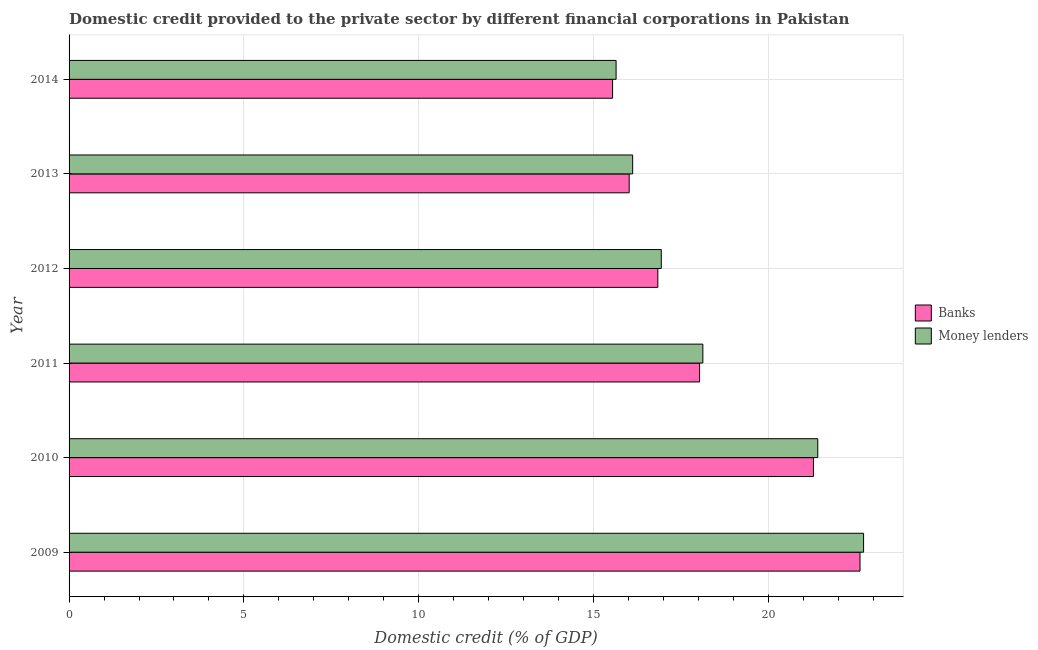How many different coloured bars are there?
Make the answer very short. 2. How many groups of bars are there?
Make the answer very short. 6. How many bars are there on the 1st tick from the top?
Keep it short and to the point. 2. How many bars are there on the 1st tick from the bottom?
Offer a very short reply. 2. What is the domestic credit provided by money lenders in 2011?
Offer a terse response. 18.13. Across all years, what is the maximum domestic credit provided by money lenders?
Make the answer very short. 22.72. Across all years, what is the minimum domestic credit provided by banks?
Offer a terse response. 15.54. What is the total domestic credit provided by money lenders in the graph?
Offer a terse response. 110.96. What is the difference between the domestic credit provided by money lenders in 2010 and that in 2012?
Provide a succinct answer. 4.48. What is the difference between the domestic credit provided by banks in 2009 and the domestic credit provided by money lenders in 2014?
Provide a succinct answer. 6.98. What is the average domestic credit provided by banks per year?
Your answer should be compact. 18.39. In the year 2012, what is the difference between the domestic credit provided by money lenders and domestic credit provided by banks?
Your answer should be compact. 0.1. What is the ratio of the domestic credit provided by banks in 2009 to that in 2014?
Offer a terse response. 1.46. Is the difference between the domestic credit provided by money lenders in 2009 and 2013 greater than the difference between the domestic credit provided by banks in 2009 and 2013?
Offer a very short reply. Yes. What is the difference between the highest and the second highest domestic credit provided by banks?
Keep it short and to the point. 1.33. What is the difference between the highest and the lowest domestic credit provided by money lenders?
Offer a terse response. 7.08. In how many years, is the domestic credit provided by banks greater than the average domestic credit provided by banks taken over all years?
Provide a succinct answer. 2. What does the 2nd bar from the top in 2009 represents?
Your answer should be very brief. Banks. What does the 1st bar from the bottom in 2009 represents?
Give a very brief answer. Banks. What is the difference between two consecutive major ticks on the X-axis?
Your answer should be compact. 5. Are the values on the major ticks of X-axis written in scientific E-notation?
Give a very brief answer. No. Where does the legend appear in the graph?
Make the answer very short. Center right. How are the legend labels stacked?
Your answer should be compact. Vertical. What is the title of the graph?
Ensure brevity in your answer.  Domestic credit provided to the private sector by different financial corporations in Pakistan. What is the label or title of the X-axis?
Keep it short and to the point. Domestic credit (% of GDP). What is the label or title of the Y-axis?
Your response must be concise. Year. What is the Domestic credit (% of GDP) of Banks in 2009?
Your answer should be very brief. 22.62. What is the Domestic credit (% of GDP) in Money lenders in 2009?
Give a very brief answer. 22.72. What is the Domestic credit (% of GDP) of Banks in 2010?
Keep it short and to the point. 21.29. What is the Domestic credit (% of GDP) of Money lenders in 2010?
Provide a short and direct response. 21.41. What is the Domestic credit (% of GDP) in Banks in 2011?
Offer a very short reply. 18.03. What is the Domestic credit (% of GDP) of Money lenders in 2011?
Your response must be concise. 18.13. What is the Domestic credit (% of GDP) of Banks in 2012?
Make the answer very short. 16.84. What is the Domestic credit (% of GDP) of Money lenders in 2012?
Provide a succinct answer. 16.94. What is the Domestic credit (% of GDP) in Banks in 2013?
Your answer should be compact. 16.02. What is the Domestic credit (% of GDP) in Money lenders in 2013?
Provide a succinct answer. 16.12. What is the Domestic credit (% of GDP) of Banks in 2014?
Give a very brief answer. 15.54. What is the Domestic credit (% of GDP) of Money lenders in 2014?
Your answer should be compact. 15.64. Across all years, what is the maximum Domestic credit (% of GDP) in Banks?
Give a very brief answer. 22.62. Across all years, what is the maximum Domestic credit (% of GDP) of Money lenders?
Make the answer very short. 22.72. Across all years, what is the minimum Domestic credit (% of GDP) of Banks?
Offer a terse response. 15.54. Across all years, what is the minimum Domestic credit (% of GDP) of Money lenders?
Give a very brief answer. 15.64. What is the total Domestic credit (% of GDP) in Banks in the graph?
Offer a terse response. 110.34. What is the total Domestic credit (% of GDP) in Money lenders in the graph?
Your answer should be very brief. 110.96. What is the difference between the Domestic credit (% of GDP) of Banks in 2009 and that in 2010?
Give a very brief answer. 1.33. What is the difference between the Domestic credit (% of GDP) in Money lenders in 2009 and that in 2010?
Provide a succinct answer. 1.31. What is the difference between the Domestic credit (% of GDP) of Banks in 2009 and that in 2011?
Keep it short and to the point. 4.59. What is the difference between the Domestic credit (% of GDP) of Money lenders in 2009 and that in 2011?
Offer a very short reply. 4.6. What is the difference between the Domestic credit (% of GDP) in Banks in 2009 and that in 2012?
Give a very brief answer. 5.78. What is the difference between the Domestic credit (% of GDP) of Money lenders in 2009 and that in 2012?
Your answer should be very brief. 5.79. What is the difference between the Domestic credit (% of GDP) in Banks in 2009 and that in 2013?
Provide a short and direct response. 6.6. What is the difference between the Domestic credit (% of GDP) of Money lenders in 2009 and that in 2013?
Make the answer very short. 6.6. What is the difference between the Domestic credit (% of GDP) in Banks in 2009 and that in 2014?
Provide a short and direct response. 7.08. What is the difference between the Domestic credit (% of GDP) of Money lenders in 2009 and that in 2014?
Ensure brevity in your answer.  7.08. What is the difference between the Domestic credit (% of GDP) in Banks in 2010 and that in 2011?
Make the answer very short. 3.26. What is the difference between the Domestic credit (% of GDP) of Money lenders in 2010 and that in 2011?
Your response must be concise. 3.29. What is the difference between the Domestic credit (% of GDP) of Banks in 2010 and that in 2012?
Offer a terse response. 4.45. What is the difference between the Domestic credit (% of GDP) of Money lenders in 2010 and that in 2012?
Ensure brevity in your answer.  4.48. What is the difference between the Domestic credit (% of GDP) of Banks in 2010 and that in 2013?
Provide a succinct answer. 5.27. What is the difference between the Domestic credit (% of GDP) in Money lenders in 2010 and that in 2013?
Provide a short and direct response. 5.29. What is the difference between the Domestic credit (% of GDP) of Banks in 2010 and that in 2014?
Your response must be concise. 5.74. What is the difference between the Domestic credit (% of GDP) of Money lenders in 2010 and that in 2014?
Your answer should be very brief. 5.77. What is the difference between the Domestic credit (% of GDP) of Banks in 2011 and that in 2012?
Provide a short and direct response. 1.19. What is the difference between the Domestic credit (% of GDP) of Money lenders in 2011 and that in 2012?
Provide a succinct answer. 1.19. What is the difference between the Domestic credit (% of GDP) of Banks in 2011 and that in 2013?
Provide a short and direct response. 2.01. What is the difference between the Domestic credit (% of GDP) of Money lenders in 2011 and that in 2013?
Your response must be concise. 2.01. What is the difference between the Domestic credit (% of GDP) of Banks in 2011 and that in 2014?
Offer a very short reply. 2.49. What is the difference between the Domestic credit (% of GDP) of Money lenders in 2011 and that in 2014?
Offer a terse response. 2.48. What is the difference between the Domestic credit (% of GDP) in Banks in 2012 and that in 2013?
Make the answer very short. 0.82. What is the difference between the Domestic credit (% of GDP) of Money lenders in 2012 and that in 2013?
Make the answer very short. 0.82. What is the difference between the Domestic credit (% of GDP) in Banks in 2012 and that in 2014?
Give a very brief answer. 1.29. What is the difference between the Domestic credit (% of GDP) of Money lenders in 2012 and that in 2014?
Provide a succinct answer. 1.29. What is the difference between the Domestic credit (% of GDP) in Banks in 2013 and that in 2014?
Offer a very short reply. 0.47. What is the difference between the Domestic credit (% of GDP) of Money lenders in 2013 and that in 2014?
Your response must be concise. 0.47. What is the difference between the Domestic credit (% of GDP) of Banks in 2009 and the Domestic credit (% of GDP) of Money lenders in 2010?
Your answer should be very brief. 1.21. What is the difference between the Domestic credit (% of GDP) of Banks in 2009 and the Domestic credit (% of GDP) of Money lenders in 2011?
Ensure brevity in your answer.  4.49. What is the difference between the Domestic credit (% of GDP) in Banks in 2009 and the Domestic credit (% of GDP) in Money lenders in 2012?
Give a very brief answer. 5.68. What is the difference between the Domestic credit (% of GDP) of Banks in 2009 and the Domestic credit (% of GDP) of Money lenders in 2013?
Your response must be concise. 6.5. What is the difference between the Domestic credit (% of GDP) of Banks in 2009 and the Domestic credit (% of GDP) of Money lenders in 2014?
Provide a short and direct response. 6.98. What is the difference between the Domestic credit (% of GDP) of Banks in 2010 and the Domestic credit (% of GDP) of Money lenders in 2011?
Make the answer very short. 3.16. What is the difference between the Domestic credit (% of GDP) of Banks in 2010 and the Domestic credit (% of GDP) of Money lenders in 2012?
Offer a very short reply. 4.35. What is the difference between the Domestic credit (% of GDP) of Banks in 2010 and the Domestic credit (% of GDP) of Money lenders in 2013?
Make the answer very short. 5.17. What is the difference between the Domestic credit (% of GDP) of Banks in 2010 and the Domestic credit (% of GDP) of Money lenders in 2014?
Give a very brief answer. 5.64. What is the difference between the Domestic credit (% of GDP) in Banks in 2011 and the Domestic credit (% of GDP) in Money lenders in 2012?
Offer a terse response. 1.09. What is the difference between the Domestic credit (% of GDP) in Banks in 2011 and the Domestic credit (% of GDP) in Money lenders in 2013?
Give a very brief answer. 1.91. What is the difference between the Domestic credit (% of GDP) in Banks in 2011 and the Domestic credit (% of GDP) in Money lenders in 2014?
Offer a terse response. 2.39. What is the difference between the Domestic credit (% of GDP) of Banks in 2012 and the Domestic credit (% of GDP) of Money lenders in 2013?
Provide a succinct answer. 0.72. What is the difference between the Domestic credit (% of GDP) of Banks in 2012 and the Domestic credit (% of GDP) of Money lenders in 2014?
Keep it short and to the point. 1.19. What is the difference between the Domestic credit (% of GDP) of Banks in 2013 and the Domestic credit (% of GDP) of Money lenders in 2014?
Your answer should be very brief. 0.37. What is the average Domestic credit (% of GDP) of Banks per year?
Your response must be concise. 18.39. What is the average Domestic credit (% of GDP) in Money lenders per year?
Give a very brief answer. 18.49. In the year 2009, what is the difference between the Domestic credit (% of GDP) of Banks and Domestic credit (% of GDP) of Money lenders?
Your answer should be very brief. -0.1. In the year 2010, what is the difference between the Domestic credit (% of GDP) of Banks and Domestic credit (% of GDP) of Money lenders?
Offer a terse response. -0.12. In the year 2011, what is the difference between the Domestic credit (% of GDP) of Banks and Domestic credit (% of GDP) of Money lenders?
Your answer should be very brief. -0.09. In the year 2012, what is the difference between the Domestic credit (% of GDP) of Banks and Domestic credit (% of GDP) of Money lenders?
Your answer should be compact. -0.1. In the year 2013, what is the difference between the Domestic credit (% of GDP) of Banks and Domestic credit (% of GDP) of Money lenders?
Offer a very short reply. -0.1. In the year 2014, what is the difference between the Domestic credit (% of GDP) in Banks and Domestic credit (% of GDP) in Money lenders?
Offer a very short reply. -0.1. What is the ratio of the Domestic credit (% of GDP) of Banks in 2009 to that in 2010?
Offer a terse response. 1.06. What is the ratio of the Domestic credit (% of GDP) of Money lenders in 2009 to that in 2010?
Keep it short and to the point. 1.06. What is the ratio of the Domestic credit (% of GDP) in Banks in 2009 to that in 2011?
Offer a terse response. 1.25. What is the ratio of the Domestic credit (% of GDP) in Money lenders in 2009 to that in 2011?
Provide a succinct answer. 1.25. What is the ratio of the Domestic credit (% of GDP) in Banks in 2009 to that in 2012?
Your answer should be compact. 1.34. What is the ratio of the Domestic credit (% of GDP) of Money lenders in 2009 to that in 2012?
Your response must be concise. 1.34. What is the ratio of the Domestic credit (% of GDP) in Banks in 2009 to that in 2013?
Offer a very short reply. 1.41. What is the ratio of the Domestic credit (% of GDP) of Money lenders in 2009 to that in 2013?
Your answer should be compact. 1.41. What is the ratio of the Domestic credit (% of GDP) of Banks in 2009 to that in 2014?
Offer a terse response. 1.46. What is the ratio of the Domestic credit (% of GDP) in Money lenders in 2009 to that in 2014?
Keep it short and to the point. 1.45. What is the ratio of the Domestic credit (% of GDP) in Banks in 2010 to that in 2011?
Provide a short and direct response. 1.18. What is the ratio of the Domestic credit (% of GDP) of Money lenders in 2010 to that in 2011?
Ensure brevity in your answer.  1.18. What is the ratio of the Domestic credit (% of GDP) in Banks in 2010 to that in 2012?
Keep it short and to the point. 1.26. What is the ratio of the Domestic credit (% of GDP) in Money lenders in 2010 to that in 2012?
Offer a terse response. 1.26. What is the ratio of the Domestic credit (% of GDP) of Banks in 2010 to that in 2013?
Ensure brevity in your answer.  1.33. What is the ratio of the Domestic credit (% of GDP) of Money lenders in 2010 to that in 2013?
Keep it short and to the point. 1.33. What is the ratio of the Domestic credit (% of GDP) in Banks in 2010 to that in 2014?
Provide a short and direct response. 1.37. What is the ratio of the Domestic credit (% of GDP) of Money lenders in 2010 to that in 2014?
Offer a terse response. 1.37. What is the ratio of the Domestic credit (% of GDP) of Banks in 2011 to that in 2012?
Your answer should be compact. 1.07. What is the ratio of the Domestic credit (% of GDP) in Money lenders in 2011 to that in 2012?
Your response must be concise. 1.07. What is the ratio of the Domestic credit (% of GDP) of Banks in 2011 to that in 2013?
Your answer should be very brief. 1.13. What is the ratio of the Domestic credit (% of GDP) in Money lenders in 2011 to that in 2013?
Give a very brief answer. 1.12. What is the ratio of the Domestic credit (% of GDP) in Banks in 2011 to that in 2014?
Make the answer very short. 1.16. What is the ratio of the Domestic credit (% of GDP) of Money lenders in 2011 to that in 2014?
Offer a terse response. 1.16. What is the ratio of the Domestic credit (% of GDP) of Banks in 2012 to that in 2013?
Ensure brevity in your answer.  1.05. What is the ratio of the Domestic credit (% of GDP) of Money lenders in 2012 to that in 2013?
Offer a terse response. 1.05. What is the ratio of the Domestic credit (% of GDP) of Money lenders in 2012 to that in 2014?
Your answer should be very brief. 1.08. What is the ratio of the Domestic credit (% of GDP) of Banks in 2013 to that in 2014?
Your answer should be very brief. 1.03. What is the ratio of the Domestic credit (% of GDP) of Money lenders in 2013 to that in 2014?
Your response must be concise. 1.03. What is the difference between the highest and the second highest Domestic credit (% of GDP) in Banks?
Ensure brevity in your answer.  1.33. What is the difference between the highest and the second highest Domestic credit (% of GDP) of Money lenders?
Give a very brief answer. 1.31. What is the difference between the highest and the lowest Domestic credit (% of GDP) of Banks?
Your answer should be very brief. 7.08. What is the difference between the highest and the lowest Domestic credit (% of GDP) of Money lenders?
Offer a terse response. 7.08. 